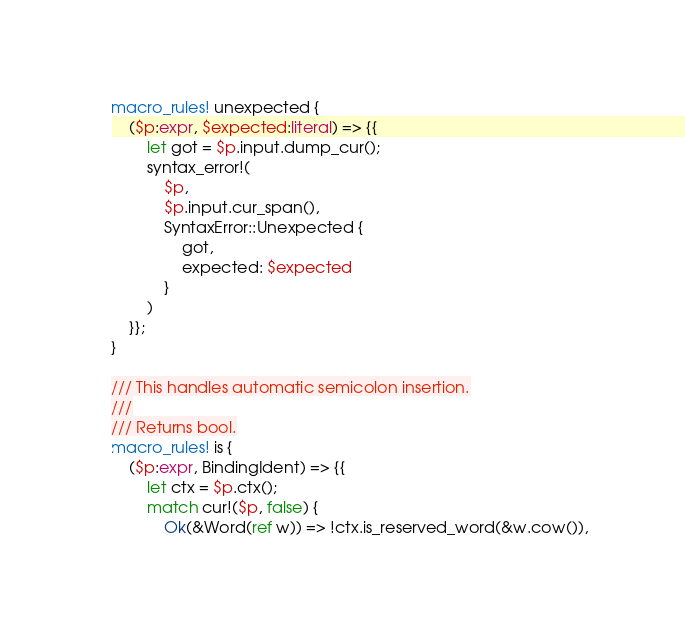<code> <loc_0><loc_0><loc_500><loc_500><_Rust_>macro_rules! unexpected {
    ($p:expr, $expected:literal) => {{
        let got = $p.input.dump_cur();
        syntax_error!(
            $p,
            $p.input.cur_span(),
            SyntaxError::Unexpected {
                got,
                expected: $expected
            }
        )
    }};
}

/// This handles automatic semicolon insertion.
///
/// Returns bool.
macro_rules! is {
    ($p:expr, BindingIdent) => {{
        let ctx = $p.ctx();
        match cur!($p, false) {
            Ok(&Word(ref w)) => !ctx.is_reserved_word(&w.cow()),</code> 